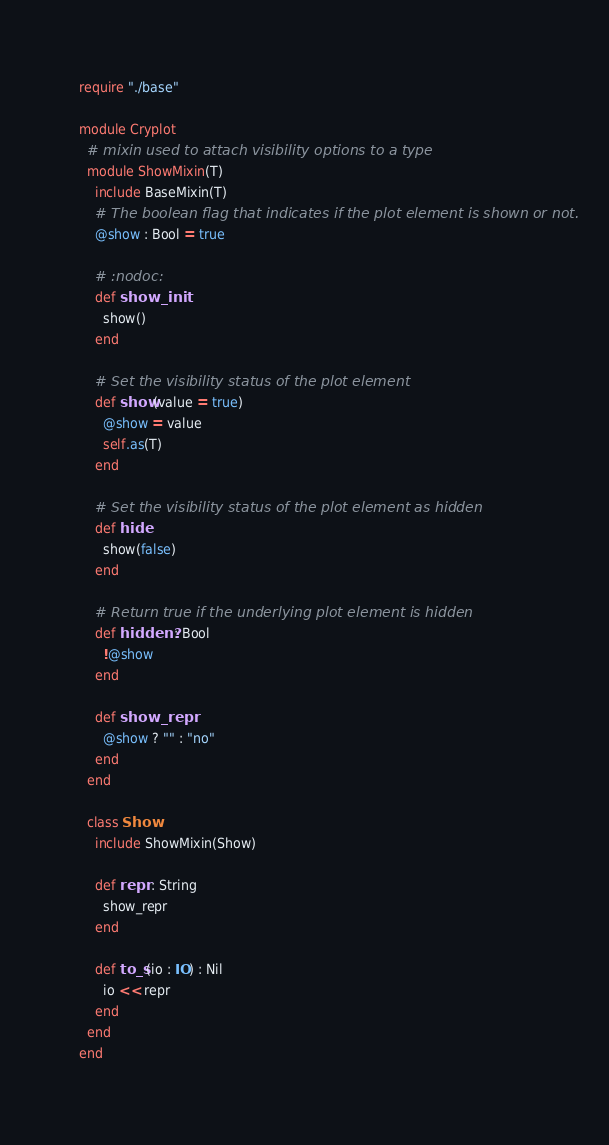Convert code to text. <code><loc_0><loc_0><loc_500><loc_500><_Crystal_>require "./base"

module Cryplot
  # mixin used to attach visibility options to a type
  module ShowMixin(T)
    include BaseMixin(T)
    # The boolean flag that indicates if the plot element is shown or not.
    @show : Bool = true

    # :nodoc:
    def show_init
      show()
    end

    # Set the visibility status of the plot element
    def show(value = true)
      @show = value
      self.as(T)
    end

    # Set the visibility status of the plot element as hidden
    def hide
      show(false)
    end

    # Return true if the underlying plot element is hidden
    def hidden? : Bool
      !@show
    end

    def show_repr
      @show ? "" : "no"
    end
  end

  class Show
    include ShowMixin(Show)

    def repr : String
      show_repr
    end

    def to_s(io : IO) : Nil
      io << repr
    end
  end
end
</code> 